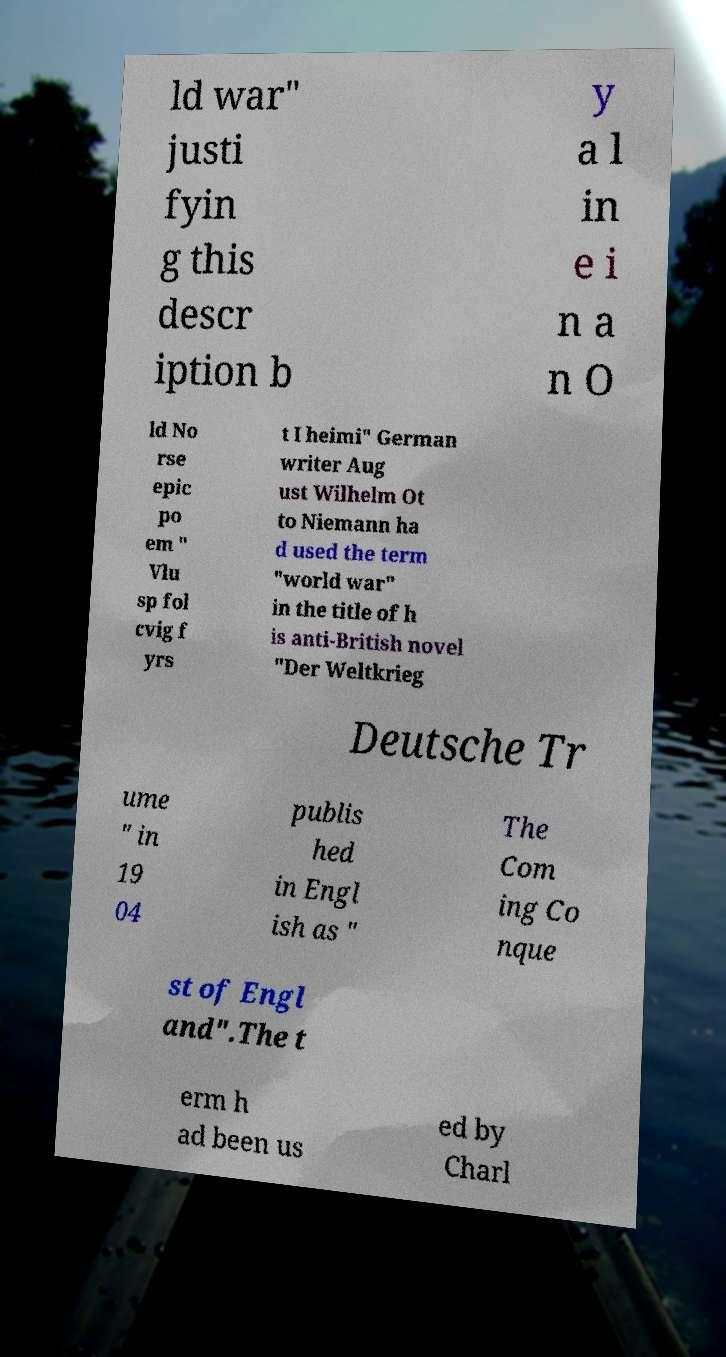What messages or text are displayed in this image? I need them in a readable, typed format. ld war" justi fyin g this descr iption b y a l in e i n a n O ld No rse epic po em " Vlu sp fol cvig f yrs t I heimi" German writer Aug ust Wilhelm Ot to Niemann ha d used the term "world war" in the title of h is anti-British novel "Der Weltkrieg Deutsche Tr ume " in 19 04 publis hed in Engl ish as " The Com ing Co nque st of Engl and".The t erm h ad been us ed by Charl 